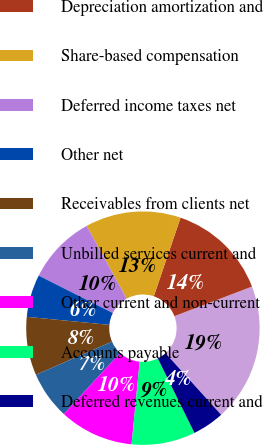Convert chart. <chart><loc_0><loc_0><loc_500><loc_500><pie_chart><fcel>Net income<fcel>Depreciation amortization and<fcel>Share-based compensation<fcel>Deferred income taxes net<fcel>Other net<fcel>Receivables from clients net<fcel>Unbilled services current and<fcel>Other current and non-current<fcel>Accounts payable<fcel>Deferred revenues current and<nl><fcel>19.11%<fcel>13.97%<fcel>13.23%<fcel>9.56%<fcel>5.88%<fcel>8.09%<fcel>6.62%<fcel>10.29%<fcel>8.82%<fcel>4.41%<nl></chart> 